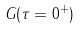Convert formula to latex. <formula><loc_0><loc_0><loc_500><loc_500>G ( \tau = 0 ^ { + } )</formula> 